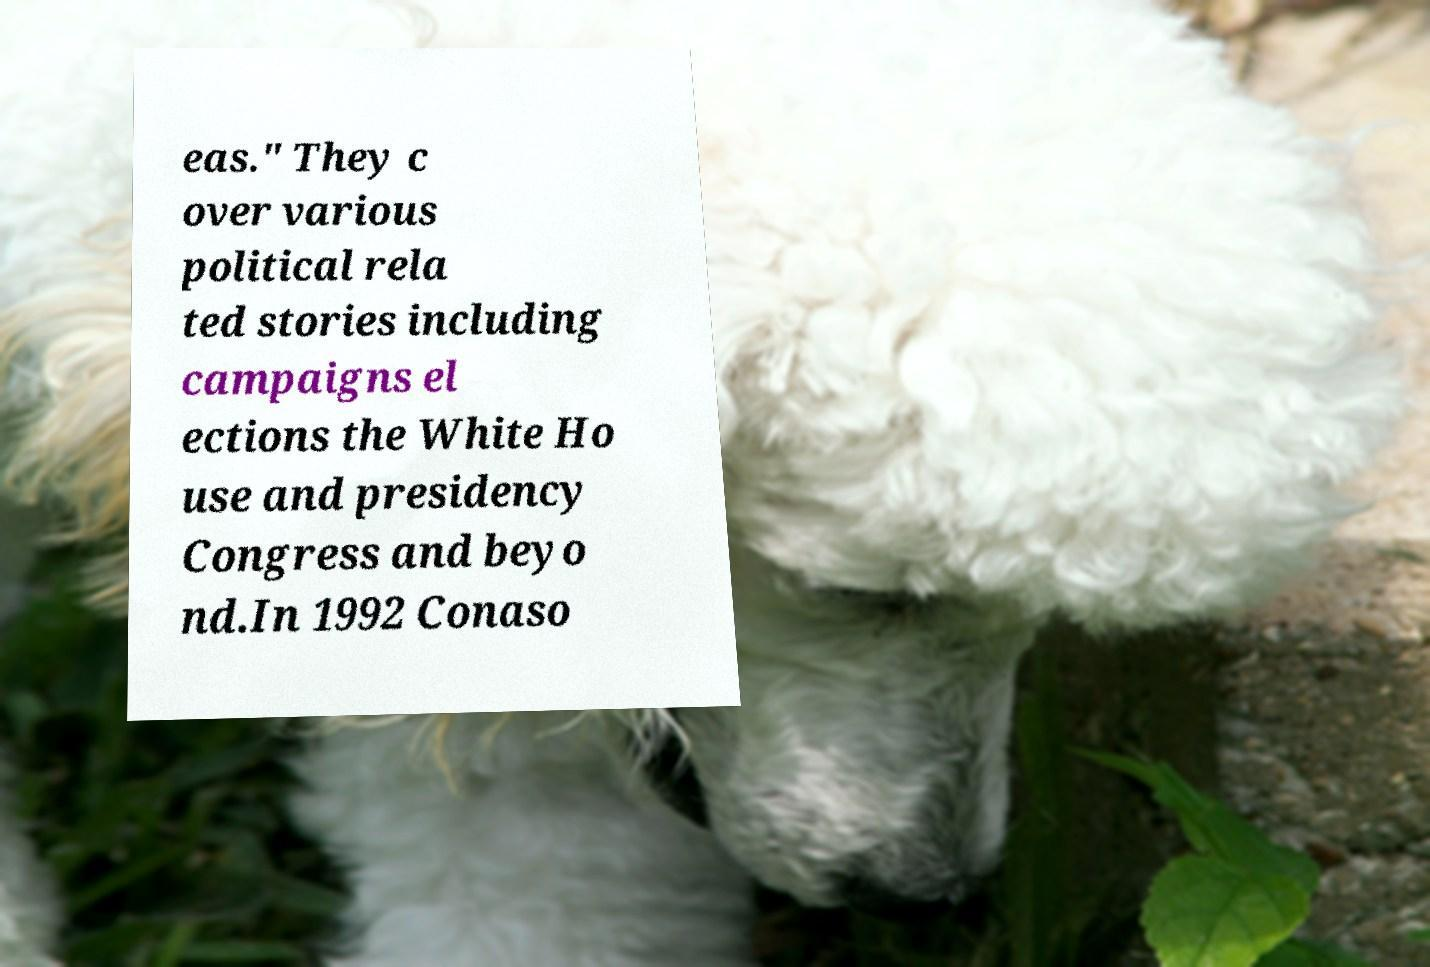Please identify and transcribe the text found in this image. eas." They c over various political rela ted stories including campaigns el ections the White Ho use and presidency Congress and beyo nd.In 1992 Conaso 